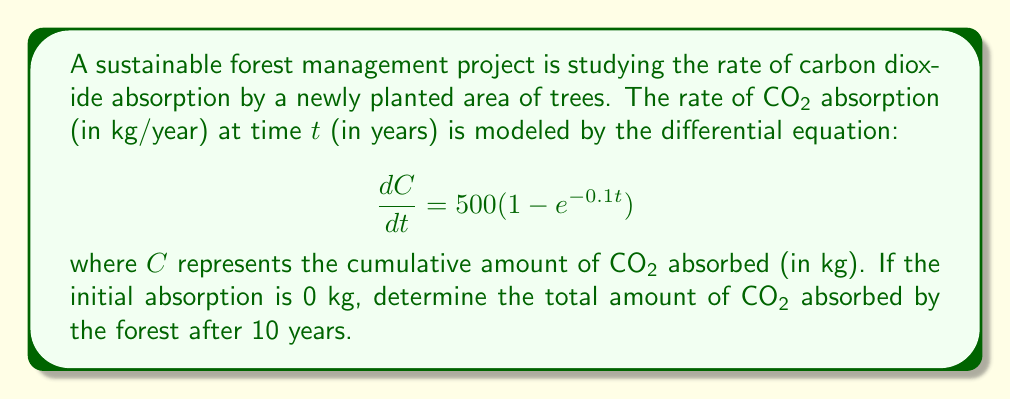Could you help me with this problem? To solve this problem, we need to integrate the given differential equation:

1) We start with the equation:
   $$\frac{dC}{dt} = 500(1 - e^{-0.1t})$$

2) To find C, we need to integrate both sides with respect to t:
   $$\int dC = \int 500(1 - e^{-0.1t}) dt$$

3) Integrating the right side:
   $$C = 500t + \frac{500}{0.1}e^{-0.1t} + K$$
   where K is the constant of integration.

4) To determine K, we use the initial condition. At t = 0, C = 0:
   $$0 = 500(0) + \frac{500}{0.1}e^{-0.1(0)} + K$$
   $$0 = 5000 + K$$
   $$K = -5000$$

5) Therefore, the general solution is:
   $$C = 500t + 5000e^{-0.1t} - 5000$$

6) To find the amount of CO₂ absorbed after 10 years, we substitute t = 10:
   $$C(10) = 500(10) + 5000e^{-0.1(10)} - 5000$$
   $$= 5000 + 5000e^{-1} - 5000$$
   $$= 5000 + 5000(0.3679) - 5000$$
   $$= 1839.5$$

Therefore, after 10 years, the forest will have absorbed approximately 1839.5 kg of CO₂.
Answer: The total amount of CO₂ absorbed by the forest after 10 years is approximately 1839.5 kg. 